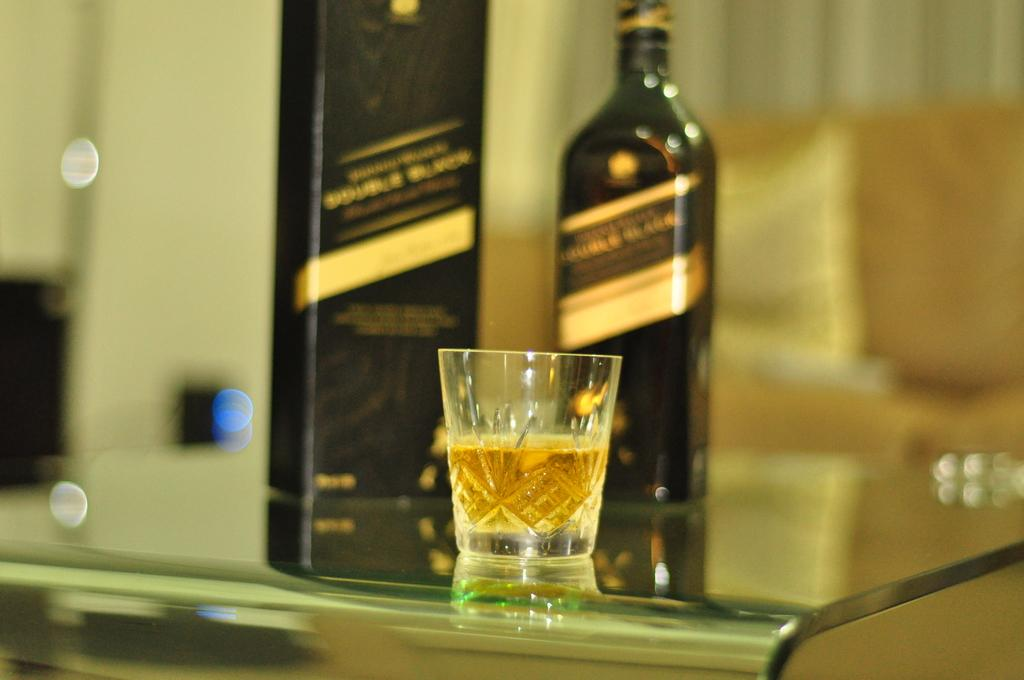What is in the glass that is visible in the image? There is a glass with alcohol in the image. What other objects can be seen in the image? There is a bottle and a box visible in the image. Where are these objects located? The objects are on a glass table. Can you describe the background of the image? The background of the image is blurred. Reasoning: Let' Let's think step by step in order to produce the conversation. We start by identifying the main subject in the image, which is the glass with alcohol. Then, we expand the conversation to include other objects that are also visible, such as the bottle and the box. We also mention the location of these objects, which is on a glass table. Finally, we describe the background of the image, which is blurred. Each question is designed to elicit a specific detail about the image that is known from the provided facts. Absurd Question/Answer: How does the glue hold the objects together in the image? There is no glue present in the image, and the objects are not attached to each other. What type of experience can be seen in the image? There is no experience visible in the image; it is a still image of objects on a table. 